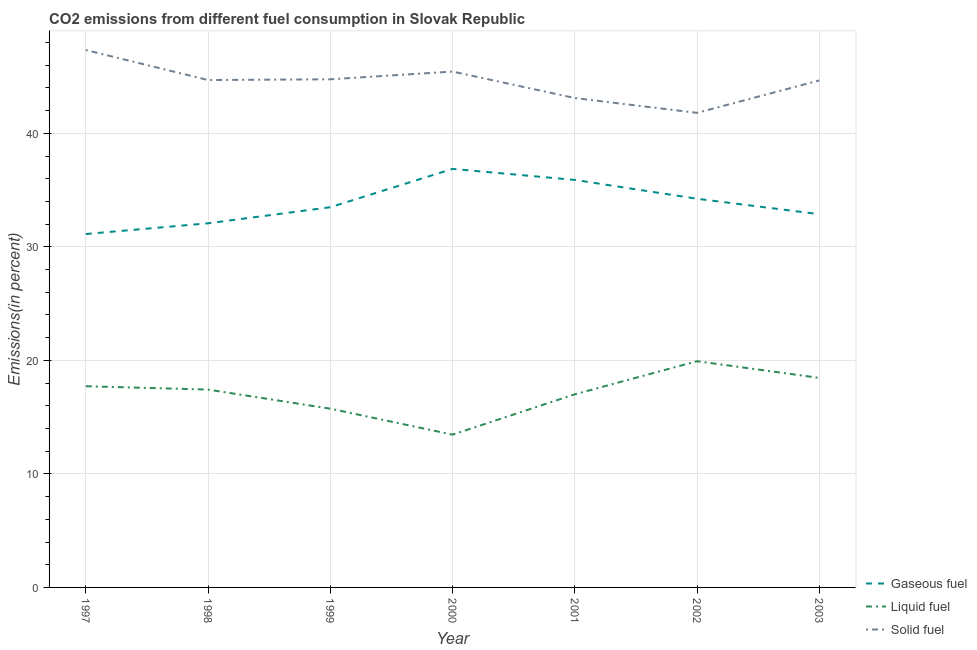How many different coloured lines are there?
Ensure brevity in your answer.  3. Is the number of lines equal to the number of legend labels?
Your response must be concise. Yes. What is the percentage of liquid fuel emission in 1998?
Your answer should be very brief. 17.43. Across all years, what is the maximum percentage of liquid fuel emission?
Offer a terse response. 19.93. Across all years, what is the minimum percentage of solid fuel emission?
Offer a terse response. 41.81. What is the total percentage of solid fuel emission in the graph?
Offer a terse response. 311.82. What is the difference between the percentage of liquid fuel emission in 2001 and that in 2003?
Offer a terse response. -1.45. What is the difference between the percentage of solid fuel emission in 2003 and the percentage of liquid fuel emission in 1998?
Provide a succinct answer. 27.23. What is the average percentage of liquid fuel emission per year?
Provide a succinct answer. 17.11. In the year 2002, what is the difference between the percentage of gaseous fuel emission and percentage of solid fuel emission?
Keep it short and to the point. -7.57. What is the ratio of the percentage of solid fuel emission in 1998 to that in 2001?
Ensure brevity in your answer.  1.04. Is the percentage of liquid fuel emission in 2002 less than that in 2003?
Offer a terse response. No. What is the difference between the highest and the second highest percentage of liquid fuel emission?
Provide a succinct answer. 1.47. What is the difference between the highest and the lowest percentage of solid fuel emission?
Make the answer very short. 5.53. In how many years, is the percentage of gaseous fuel emission greater than the average percentage of gaseous fuel emission taken over all years?
Make the answer very short. 3. Is it the case that in every year, the sum of the percentage of gaseous fuel emission and percentage of liquid fuel emission is greater than the percentage of solid fuel emission?
Provide a succinct answer. Yes. Is the percentage of liquid fuel emission strictly less than the percentage of gaseous fuel emission over the years?
Give a very brief answer. Yes. What is the difference between two consecutive major ticks on the Y-axis?
Your response must be concise. 10. Does the graph contain grids?
Give a very brief answer. Yes. Where does the legend appear in the graph?
Your answer should be very brief. Bottom right. How many legend labels are there?
Your answer should be compact. 3. What is the title of the graph?
Ensure brevity in your answer.  CO2 emissions from different fuel consumption in Slovak Republic. Does "Transport equipments" appear as one of the legend labels in the graph?
Keep it short and to the point. No. What is the label or title of the Y-axis?
Offer a terse response. Emissions(in percent). What is the Emissions(in percent) in Gaseous fuel in 1997?
Provide a succinct answer. 31.13. What is the Emissions(in percent) in Liquid fuel in 1997?
Ensure brevity in your answer.  17.72. What is the Emissions(in percent) in Solid fuel in 1997?
Offer a very short reply. 47.34. What is the Emissions(in percent) in Gaseous fuel in 1998?
Give a very brief answer. 32.08. What is the Emissions(in percent) in Liquid fuel in 1998?
Give a very brief answer. 17.43. What is the Emissions(in percent) in Solid fuel in 1998?
Give a very brief answer. 44.7. What is the Emissions(in percent) of Gaseous fuel in 1999?
Your answer should be compact. 33.49. What is the Emissions(in percent) in Liquid fuel in 1999?
Offer a terse response. 15.75. What is the Emissions(in percent) of Solid fuel in 1999?
Offer a terse response. 44.76. What is the Emissions(in percent) of Gaseous fuel in 2000?
Your response must be concise. 36.87. What is the Emissions(in percent) in Liquid fuel in 2000?
Provide a short and direct response. 13.46. What is the Emissions(in percent) in Solid fuel in 2000?
Ensure brevity in your answer.  45.44. What is the Emissions(in percent) in Gaseous fuel in 2001?
Ensure brevity in your answer.  35.9. What is the Emissions(in percent) of Liquid fuel in 2001?
Keep it short and to the point. 17.01. What is the Emissions(in percent) in Solid fuel in 2001?
Provide a short and direct response. 43.11. What is the Emissions(in percent) in Gaseous fuel in 2002?
Provide a succinct answer. 34.24. What is the Emissions(in percent) in Liquid fuel in 2002?
Your response must be concise. 19.93. What is the Emissions(in percent) of Solid fuel in 2002?
Your answer should be very brief. 41.81. What is the Emissions(in percent) of Gaseous fuel in 2003?
Your response must be concise. 32.88. What is the Emissions(in percent) in Liquid fuel in 2003?
Offer a very short reply. 18.46. What is the Emissions(in percent) of Solid fuel in 2003?
Your answer should be compact. 44.66. Across all years, what is the maximum Emissions(in percent) in Gaseous fuel?
Ensure brevity in your answer.  36.87. Across all years, what is the maximum Emissions(in percent) of Liquid fuel?
Provide a succinct answer. 19.93. Across all years, what is the maximum Emissions(in percent) of Solid fuel?
Your response must be concise. 47.34. Across all years, what is the minimum Emissions(in percent) of Gaseous fuel?
Your response must be concise. 31.13. Across all years, what is the minimum Emissions(in percent) in Liquid fuel?
Offer a very short reply. 13.46. Across all years, what is the minimum Emissions(in percent) of Solid fuel?
Your response must be concise. 41.81. What is the total Emissions(in percent) in Gaseous fuel in the graph?
Make the answer very short. 236.59. What is the total Emissions(in percent) in Liquid fuel in the graph?
Provide a short and direct response. 119.76. What is the total Emissions(in percent) of Solid fuel in the graph?
Your answer should be compact. 311.82. What is the difference between the Emissions(in percent) in Gaseous fuel in 1997 and that in 1998?
Give a very brief answer. -0.94. What is the difference between the Emissions(in percent) of Liquid fuel in 1997 and that in 1998?
Offer a terse response. 0.29. What is the difference between the Emissions(in percent) in Solid fuel in 1997 and that in 1998?
Your answer should be compact. 2.64. What is the difference between the Emissions(in percent) in Gaseous fuel in 1997 and that in 1999?
Provide a short and direct response. -2.36. What is the difference between the Emissions(in percent) of Liquid fuel in 1997 and that in 1999?
Provide a succinct answer. 1.98. What is the difference between the Emissions(in percent) in Solid fuel in 1997 and that in 1999?
Offer a very short reply. 2.58. What is the difference between the Emissions(in percent) of Gaseous fuel in 1997 and that in 2000?
Provide a succinct answer. -5.74. What is the difference between the Emissions(in percent) in Liquid fuel in 1997 and that in 2000?
Your answer should be compact. 4.27. What is the difference between the Emissions(in percent) in Solid fuel in 1997 and that in 2000?
Your answer should be very brief. 1.9. What is the difference between the Emissions(in percent) in Gaseous fuel in 1997 and that in 2001?
Provide a short and direct response. -4.77. What is the difference between the Emissions(in percent) in Liquid fuel in 1997 and that in 2001?
Your answer should be very brief. 0.71. What is the difference between the Emissions(in percent) in Solid fuel in 1997 and that in 2001?
Make the answer very short. 4.23. What is the difference between the Emissions(in percent) of Gaseous fuel in 1997 and that in 2002?
Offer a terse response. -3.11. What is the difference between the Emissions(in percent) of Liquid fuel in 1997 and that in 2002?
Ensure brevity in your answer.  -2.2. What is the difference between the Emissions(in percent) in Solid fuel in 1997 and that in 2002?
Make the answer very short. 5.53. What is the difference between the Emissions(in percent) of Gaseous fuel in 1997 and that in 2003?
Provide a succinct answer. -1.75. What is the difference between the Emissions(in percent) of Liquid fuel in 1997 and that in 2003?
Provide a succinct answer. -0.73. What is the difference between the Emissions(in percent) in Solid fuel in 1997 and that in 2003?
Your response must be concise. 2.68. What is the difference between the Emissions(in percent) of Gaseous fuel in 1998 and that in 1999?
Provide a succinct answer. -1.42. What is the difference between the Emissions(in percent) in Liquid fuel in 1998 and that in 1999?
Your answer should be very brief. 1.68. What is the difference between the Emissions(in percent) in Solid fuel in 1998 and that in 1999?
Offer a terse response. -0.07. What is the difference between the Emissions(in percent) of Gaseous fuel in 1998 and that in 2000?
Provide a succinct answer. -4.79. What is the difference between the Emissions(in percent) of Liquid fuel in 1998 and that in 2000?
Offer a terse response. 3.97. What is the difference between the Emissions(in percent) of Solid fuel in 1998 and that in 2000?
Give a very brief answer. -0.75. What is the difference between the Emissions(in percent) in Gaseous fuel in 1998 and that in 2001?
Your answer should be very brief. -3.82. What is the difference between the Emissions(in percent) of Liquid fuel in 1998 and that in 2001?
Your answer should be very brief. 0.42. What is the difference between the Emissions(in percent) of Solid fuel in 1998 and that in 2001?
Keep it short and to the point. 1.59. What is the difference between the Emissions(in percent) of Gaseous fuel in 1998 and that in 2002?
Make the answer very short. -2.16. What is the difference between the Emissions(in percent) in Liquid fuel in 1998 and that in 2002?
Provide a succinct answer. -2.5. What is the difference between the Emissions(in percent) of Solid fuel in 1998 and that in 2002?
Keep it short and to the point. 2.89. What is the difference between the Emissions(in percent) in Gaseous fuel in 1998 and that in 2003?
Provide a short and direct response. -0.8. What is the difference between the Emissions(in percent) of Liquid fuel in 1998 and that in 2003?
Offer a terse response. -1.03. What is the difference between the Emissions(in percent) in Solid fuel in 1998 and that in 2003?
Offer a very short reply. 0.04. What is the difference between the Emissions(in percent) of Gaseous fuel in 1999 and that in 2000?
Your answer should be very brief. -3.38. What is the difference between the Emissions(in percent) in Liquid fuel in 1999 and that in 2000?
Provide a short and direct response. 2.29. What is the difference between the Emissions(in percent) of Solid fuel in 1999 and that in 2000?
Offer a terse response. -0.68. What is the difference between the Emissions(in percent) of Gaseous fuel in 1999 and that in 2001?
Keep it short and to the point. -2.41. What is the difference between the Emissions(in percent) in Liquid fuel in 1999 and that in 2001?
Make the answer very short. -1.27. What is the difference between the Emissions(in percent) of Solid fuel in 1999 and that in 2001?
Your answer should be compact. 1.65. What is the difference between the Emissions(in percent) in Gaseous fuel in 1999 and that in 2002?
Keep it short and to the point. -0.75. What is the difference between the Emissions(in percent) of Liquid fuel in 1999 and that in 2002?
Offer a terse response. -4.18. What is the difference between the Emissions(in percent) in Solid fuel in 1999 and that in 2002?
Your answer should be compact. 2.96. What is the difference between the Emissions(in percent) in Gaseous fuel in 1999 and that in 2003?
Your response must be concise. 0.61. What is the difference between the Emissions(in percent) of Liquid fuel in 1999 and that in 2003?
Ensure brevity in your answer.  -2.71. What is the difference between the Emissions(in percent) of Solid fuel in 1999 and that in 2003?
Offer a very short reply. 0.1. What is the difference between the Emissions(in percent) of Gaseous fuel in 2000 and that in 2001?
Offer a very short reply. 0.97. What is the difference between the Emissions(in percent) of Liquid fuel in 2000 and that in 2001?
Provide a succinct answer. -3.55. What is the difference between the Emissions(in percent) in Solid fuel in 2000 and that in 2001?
Provide a succinct answer. 2.33. What is the difference between the Emissions(in percent) of Gaseous fuel in 2000 and that in 2002?
Your answer should be compact. 2.63. What is the difference between the Emissions(in percent) of Liquid fuel in 2000 and that in 2002?
Your answer should be very brief. -6.47. What is the difference between the Emissions(in percent) in Solid fuel in 2000 and that in 2002?
Offer a very short reply. 3.64. What is the difference between the Emissions(in percent) of Gaseous fuel in 2000 and that in 2003?
Your response must be concise. 3.99. What is the difference between the Emissions(in percent) of Liquid fuel in 2000 and that in 2003?
Offer a terse response. -5. What is the difference between the Emissions(in percent) of Solid fuel in 2000 and that in 2003?
Ensure brevity in your answer.  0.78. What is the difference between the Emissions(in percent) of Gaseous fuel in 2001 and that in 2002?
Your answer should be very brief. 1.66. What is the difference between the Emissions(in percent) in Liquid fuel in 2001 and that in 2002?
Your response must be concise. -2.91. What is the difference between the Emissions(in percent) of Solid fuel in 2001 and that in 2002?
Make the answer very short. 1.3. What is the difference between the Emissions(in percent) of Gaseous fuel in 2001 and that in 2003?
Your answer should be compact. 3.02. What is the difference between the Emissions(in percent) in Liquid fuel in 2001 and that in 2003?
Ensure brevity in your answer.  -1.45. What is the difference between the Emissions(in percent) in Solid fuel in 2001 and that in 2003?
Make the answer very short. -1.55. What is the difference between the Emissions(in percent) of Gaseous fuel in 2002 and that in 2003?
Provide a succinct answer. 1.36. What is the difference between the Emissions(in percent) of Liquid fuel in 2002 and that in 2003?
Provide a succinct answer. 1.47. What is the difference between the Emissions(in percent) in Solid fuel in 2002 and that in 2003?
Your answer should be compact. -2.85. What is the difference between the Emissions(in percent) of Gaseous fuel in 1997 and the Emissions(in percent) of Liquid fuel in 1998?
Provide a succinct answer. 13.7. What is the difference between the Emissions(in percent) in Gaseous fuel in 1997 and the Emissions(in percent) in Solid fuel in 1998?
Give a very brief answer. -13.56. What is the difference between the Emissions(in percent) of Liquid fuel in 1997 and the Emissions(in percent) of Solid fuel in 1998?
Provide a succinct answer. -26.97. What is the difference between the Emissions(in percent) in Gaseous fuel in 1997 and the Emissions(in percent) in Liquid fuel in 1999?
Your answer should be very brief. 15.39. What is the difference between the Emissions(in percent) in Gaseous fuel in 1997 and the Emissions(in percent) in Solid fuel in 1999?
Your answer should be very brief. -13.63. What is the difference between the Emissions(in percent) in Liquid fuel in 1997 and the Emissions(in percent) in Solid fuel in 1999?
Your answer should be very brief. -27.04. What is the difference between the Emissions(in percent) in Gaseous fuel in 1997 and the Emissions(in percent) in Liquid fuel in 2000?
Your response must be concise. 17.67. What is the difference between the Emissions(in percent) of Gaseous fuel in 1997 and the Emissions(in percent) of Solid fuel in 2000?
Keep it short and to the point. -14.31. What is the difference between the Emissions(in percent) of Liquid fuel in 1997 and the Emissions(in percent) of Solid fuel in 2000?
Make the answer very short. -27.72. What is the difference between the Emissions(in percent) of Gaseous fuel in 1997 and the Emissions(in percent) of Liquid fuel in 2001?
Your response must be concise. 14.12. What is the difference between the Emissions(in percent) of Gaseous fuel in 1997 and the Emissions(in percent) of Solid fuel in 2001?
Ensure brevity in your answer.  -11.98. What is the difference between the Emissions(in percent) in Liquid fuel in 1997 and the Emissions(in percent) in Solid fuel in 2001?
Your answer should be very brief. -25.39. What is the difference between the Emissions(in percent) in Gaseous fuel in 1997 and the Emissions(in percent) in Liquid fuel in 2002?
Your response must be concise. 11.21. What is the difference between the Emissions(in percent) of Gaseous fuel in 1997 and the Emissions(in percent) of Solid fuel in 2002?
Your answer should be very brief. -10.67. What is the difference between the Emissions(in percent) in Liquid fuel in 1997 and the Emissions(in percent) in Solid fuel in 2002?
Make the answer very short. -24.08. What is the difference between the Emissions(in percent) of Gaseous fuel in 1997 and the Emissions(in percent) of Liquid fuel in 2003?
Keep it short and to the point. 12.67. What is the difference between the Emissions(in percent) of Gaseous fuel in 1997 and the Emissions(in percent) of Solid fuel in 2003?
Provide a succinct answer. -13.53. What is the difference between the Emissions(in percent) of Liquid fuel in 1997 and the Emissions(in percent) of Solid fuel in 2003?
Offer a terse response. -26.94. What is the difference between the Emissions(in percent) of Gaseous fuel in 1998 and the Emissions(in percent) of Liquid fuel in 1999?
Your response must be concise. 16.33. What is the difference between the Emissions(in percent) of Gaseous fuel in 1998 and the Emissions(in percent) of Solid fuel in 1999?
Offer a very short reply. -12.69. What is the difference between the Emissions(in percent) in Liquid fuel in 1998 and the Emissions(in percent) in Solid fuel in 1999?
Give a very brief answer. -27.33. What is the difference between the Emissions(in percent) of Gaseous fuel in 1998 and the Emissions(in percent) of Liquid fuel in 2000?
Your answer should be compact. 18.62. What is the difference between the Emissions(in percent) in Gaseous fuel in 1998 and the Emissions(in percent) in Solid fuel in 2000?
Your answer should be compact. -13.37. What is the difference between the Emissions(in percent) of Liquid fuel in 1998 and the Emissions(in percent) of Solid fuel in 2000?
Give a very brief answer. -28.01. What is the difference between the Emissions(in percent) in Gaseous fuel in 1998 and the Emissions(in percent) in Liquid fuel in 2001?
Offer a terse response. 15.06. What is the difference between the Emissions(in percent) in Gaseous fuel in 1998 and the Emissions(in percent) in Solid fuel in 2001?
Provide a short and direct response. -11.03. What is the difference between the Emissions(in percent) in Liquid fuel in 1998 and the Emissions(in percent) in Solid fuel in 2001?
Offer a terse response. -25.68. What is the difference between the Emissions(in percent) of Gaseous fuel in 1998 and the Emissions(in percent) of Liquid fuel in 2002?
Give a very brief answer. 12.15. What is the difference between the Emissions(in percent) in Gaseous fuel in 1998 and the Emissions(in percent) in Solid fuel in 2002?
Keep it short and to the point. -9.73. What is the difference between the Emissions(in percent) of Liquid fuel in 1998 and the Emissions(in percent) of Solid fuel in 2002?
Provide a short and direct response. -24.38. What is the difference between the Emissions(in percent) of Gaseous fuel in 1998 and the Emissions(in percent) of Liquid fuel in 2003?
Make the answer very short. 13.62. What is the difference between the Emissions(in percent) of Gaseous fuel in 1998 and the Emissions(in percent) of Solid fuel in 2003?
Ensure brevity in your answer.  -12.58. What is the difference between the Emissions(in percent) in Liquid fuel in 1998 and the Emissions(in percent) in Solid fuel in 2003?
Provide a succinct answer. -27.23. What is the difference between the Emissions(in percent) of Gaseous fuel in 1999 and the Emissions(in percent) of Liquid fuel in 2000?
Make the answer very short. 20.03. What is the difference between the Emissions(in percent) in Gaseous fuel in 1999 and the Emissions(in percent) in Solid fuel in 2000?
Your answer should be compact. -11.95. What is the difference between the Emissions(in percent) in Liquid fuel in 1999 and the Emissions(in percent) in Solid fuel in 2000?
Provide a short and direct response. -29.7. What is the difference between the Emissions(in percent) in Gaseous fuel in 1999 and the Emissions(in percent) in Liquid fuel in 2001?
Provide a succinct answer. 16.48. What is the difference between the Emissions(in percent) of Gaseous fuel in 1999 and the Emissions(in percent) of Solid fuel in 2001?
Provide a succinct answer. -9.62. What is the difference between the Emissions(in percent) of Liquid fuel in 1999 and the Emissions(in percent) of Solid fuel in 2001?
Make the answer very short. -27.36. What is the difference between the Emissions(in percent) in Gaseous fuel in 1999 and the Emissions(in percent) in Liquid fuel in 2002?
Your answer should be compact. 13.57. What is the difference between the Emissions(in percent) in Gaseous fuel in 1999 and the Emissions(in percent) in Solid fuel in 2002?
Make the answer very short. -8.31. What is the difference between the Emissions(in percent) in Liquid fuel in 1999 and the Emissions(in percent) in Solid fuel in 2002?
Provide a succinct answer. -26.06. What is the difference between the Emissions(in percent) in Gaseous fuel in 1999 and the Emissions(in percent) in Liquid fuel in 2003?
Ensure brevity in your answer.  15.03. What is the difference between the Emissions(in percent) in Gaseous fuel in 1999 and the Emissions(in percent) in Solid fuel in 2003?
Your response must be concise. -11.17. What is the difference between the Emissions(in percent) of Liquid fuel in 1999 and the Emissions(in percent) of Solid fuel in 2003?
Your answer should be very brief. -28.91. What is the difference between the Emissions(in percent) of Gaseous fuel in 2000 and the Emissions(in percent) of Liquid fuel in 2001?
Give a very brief answer. 19.86. What is the difference between the Emissions(in percent) in Gaseous fuel in 2000 and the Emissions(in percent) in Solid fuel in 2001?
Keep it short and to the point. -6.24. What is the difference between the Emissions(in percent) of Liquid fuel in 2000 and the Emissions(in percent) of Solid fuel in 2001?
Ensure brevity in your answer.  -29.65. What is the difference between the Emissions(in percent) in Gaseous fuel in 2000 and the Emissions(in percent) in Liquid fuel in 2002?
Provide a short and direct response. 16.94. What is the difference between the Emissions(in percent) of Gaseous fuel in 2000 and the Emissions(in percent) of Solid fuel in 2002?
Offer a very short reply. -4.94. What is the difference between the Emissions(in percent) of Liquid fuel in 2000 and the Emissions(in percent) of Solid fuel in 2002?
Offer a terse response. -28.35. What is the difference between the Emissions(in percent) in Gaseous fuel in 2000 and the Emissions(in percent) in Liquid fuel in 2003?
Provide a succinct answer. 18.41. What is the difference between the Emissions(in percent) in Gaseous fuel in 2000 and the Emissions(in percent) in Solid fuel in 2003?
Give a very brief answer. -7.79. What is the difference between the Emissions(in percent) of Liquid fuel in 2000 and the Emissions(in percent) of Solid fuel in 2003?
Offer a terse response. -31.2. What is the difference between the Emissions(in percent) of Gaseous fuel in 2001 and the Emissions(in percent) of Liquid fuel in 2002?
Your answer should be very brief. 15.97. What is the difference between the Emissions(in percent) of Gaseous fuel in 2001 and the Emissions(in percent) of Solid fuel in 2002?
Ensure brevity in your answer.  -5.91. What is the difference between the Emissions(in percent) of Liquid fuel in 2001 and the Emissions(in percent) of Solid fuel in 2002?
Your answer should be very brief. -24.79. What is the difference between the Emissions(in percent) in Gaseous fuel in 2001 and the Emissions(in percent) in Liquid fuel in 2003?
Your response must be concise. 17.44. What is the difference between the Emissions(in percent) in Gaseous fuel in 2001 and the Emissions(in percent) in Solid fuel in 2003?
Ensure brevity in your answer.  -8.76. What is the difference between the Emissions(in percent) of Liquid fuel in 2001 and the Emissions(in percent) of Solid fuel in 2003?
Ensure brevity in your answer.  -27.65. What is the difference between the Emissions(in percent) of Gaseous fuel in 2002 and the Emissions(in percent) of Liquid fuel in 2003?
Your answer should be very brief. 15.78. What is the difference between the Emissions(in percent) in Gaseous fuel in 2002 and the Emissions(in percent) in Solid fuel in 2003?
Ensure brevity in your answer.  -10.42. What is the difference between the Emissions(in percent) of Liquid fuel in 2002 and the Emissions(in percent) of Solid fuel in 2003?
Give a very brief answer. -24.73. What is the average Emissions(in percent) of Gaseous fuel per year?
Your response must be concise. 33.8. What is the average Emissions(in percent) in Liquid fuel per year?
Give a very brief answer. 17.11. What is the average Emissions(in percent) in Solid fuel per year?
Keep it short and to the point. 44.55. In the year 1997, what is the difference between the Emissions(in percent) in Gaseous fuel and Emissions(in percent) in Liquid fuel?
Provide a succinct answer. 13.41. In the year 1997, what is the difference between the Emissions(in percent) of Gaseous fuel and Emissions(in percent) of Solid fuel?
Provide a succinct answer. -16.21. In the year 1997, what is the difference between the Emissions(in percent) of Liquid fuel and Emissions(in percent) of Solid fuel?
Provide a succinct answer. -29.61. In the year 1998, what is the difference between the Emissions(in percent) in Gaseous fuel and Emissions(in percent) in Liquid fuel?
Offer a very short reply. 14.65. In the year 1998, what is the difference between the Emissions(in percent) of Gaseous fuel and Emissions(in percent) of Solid fuel?
Ensure brevity in your answer.  -12.62. In the year 1998, what is the difference between the Emissions(in percent) in Liquid fuel and Emissions(in percent) in Solid fuel?
Provide a short and direct response. -27.27. In the year 1999, what is the difference between the Emissions(in percent) in Gaseous fuel and Emissions(in percent) in Liquid fuel?
Ensure brevity in your answer.  17.75. In the year 1999, what is the difference between the Emissions(in percent) in Gaseous fuel and Emissions(in percent) in Solid fuel?
Offer a very short reply. -11.27. In the year 1999, what is the difference between the Emissions(in percent) of Liquid fuel and Emissions(in percent) of Solid fuel?
Offer a very short reply. -29.02. In the year 2000, what is the difference between the Emissions(in percent) of Gaseous fuel and Emissions(in percent) of Liquid fuel?
Your response must be concise. 23.41. In the year 2000, what is the difference between the Emissions(in percent) of Gaseous fuel and Emissions(in percent) of Solid fuel?
Your response must be concise. -8.57. In the year 2000, what is the difference between the Emissions(in percent) in Liquid fuel and Emissions(in percent) in Solid fuel?
Offer a terse response. -31.98. In the year 2001, what is the difference between the Emissions(in percent) of Gaseous fuel and Emissions(in percent) of Liquid fuel?
Give a very brief answer. 18.89. In the year 2001, what is the difference between the Emissions(in percent) of Gaseous fuel and Emissions(in percent) of Solid fuel?
Your answer should be compact. -7.21. In the year 2001, what is the difference between the Emissions(in percent) of Liquid fuel and Emissions(in percent) of Solid fuel?
Provide a short and direct response. -26.1. In the year 2002, what is the difference between the Emissions(in percent) of Gaseous fuel and Emissions(in percent) of Liquid fuel?
Give a very brief answer. 14.31. In the year 2002, what is the difference between the Emissions(in percent) in Gaseous fuel and Emissions(in percent) in Solid fuel?
Keep it short and to the point. -7.57. In the year 2002, what is the difference between the Emissions(in percent) of Liquid fuel and Emissions(in percent) of Solid fuel?
Offer a terse response. -21.88. In the year 2003, what is the difference between the Emissions(in percent) in Gaseous fuel and Emissions(in percent) in Liquid fuel?
Offer a terse response. 14.42. In the year 2003, what is the difference between the Emissions(in percent) in Gaseous fuel and Emissions(in percent) in Solid fuel?
Provide a succinct answer. -11.78. In the year 2003, what is the difference between the Emissions(in percent) in Liquid fuel and Emissions(in percent) in Solid fuel?
Make the answer very short. -26.2. What is the ratio of the Emissions(in percent) of Gaseous fuel in 1997 to that in 1998?
Provide a succinct answer. 0.97. What is the ratio of the Emissions(in percent) in Liquid fuel in 1997 to that in 1998?
Your response must be concise. 1.02. What is the ratio of the Emissions(in percent) of Solid fuel in 1997 to that in 1998?
Offer a terse response. 1.06. What is the ratio of the Emissions(in percent) of Gaseous fuel in 1997 to that in 1999?
Keep it short and to the point. 0.93. What is the ratio of the Emissions(in percent) of Liquid fuel in 1997 to that in 1999?
Offer a terse response. 1.13. What is the ratio of the Emissions(in percent) of Solid fuel in 1997 to that in 1999?
Keep it short and to the point. 1.06. What is the ratio of the Emissions(in percent) of Gaseous fuel in 1997 to that in 2000?
Your answer should be compact. 0.84. What is the ratio of the Emissions(in percent) in Liquid fuel in 1997 to that in 2000?
Make the answer very short. 1.32. What is the ratio of the Emissions(in percent) of Solid fuel in 1997 to that in 2000?
Provide a short and direct response. 1.04. What is the ratio of the Emissions(in percent) in Gaseous fuel in 1997 to that in 2001?
Keep it short and to the point. 0.87. What is the ratio of the Emissions(in percent) in Liquid fuel in 1997 to that in 2001?
Your answer should be compact. 1.04. What is the ratio of the Emissions(in percent) in Solid fuel in 1997 to that in 2001?
Provide a short and direct response. 1.1. What is the ratio of the Emissions(in percent) of Gaseous fuel in 1997 to that in 2002?
Give a very brief answer. 0.91. What is the ratio of the Emissions(in percent) of Liquid fuel in 1997 to that in 2002?
Make the answer very short. 0.89. What is the ratio of the Emissions(in percent) of Solid fuel in 1997 to that in 2002?
Make the answer very short. 1.13. What is the ratio of the Emissions(in percent) of Gaseous fuel in 1997 to that in 2003?
Give a very brief answer. 0.95. What is the ratio of the Emissions(in percent) of Liquid fuel in 1997 to that in 2003?
Ensure brevity in your answer.  0.96. What is the ratio of the Emissions(in percent) of Solid fuel in 1997 to that in 2003?
Offer a very short reply. 1.06. What is the ratio of the Emissions(in percent) in Gaseous fuel in 1998 to that in 1999?
Your answer should be compact. 0.96. What is the ratio of the Emissions(in percent) in Liquid fuel in 1998 to that in 1999?
Make the answer very short. 1.11. What is the ratio of the Emissions(in percent) of Solid fuel in 1998 to that in 1999?
Offer a terse response. 1. What is the ratio of the Emissions(in percent) of Gaseous fuel in 1998 to that in 2000?
Your answer should be very brief. 0.87. What is the ratio of the Emissions(in percent) of Liquid fuel in 1998 to that in 2000?
Offer a terse response. 1.3. What is the ratio of the Emissions(in percent) of Solid fuel in 1998 to that in 2000?
Your answer should be compact. 0.98. What is the ratio of the Emissions(in percent) of Gaseous fuel in 1998 to that in 2001?
Offer a very short reply. 0.89. What is the ratio of the Emissions(in percent) in Liquid fuel in 1998 to that in 2001?
Give a very brief answer. 1.02. What is the ratio of the Emissions(in percent) in Solid fuel in 1998 to that in 2001?
Provide a short and direct response. 1.04. What is the ratio of the Emissions(in percent) of Gaseous fuel in 1998 to that in 2002?
Provide a short and direct response. 0.94. What is the ratio of the Emissions(in percent) in Liquid fuel in 1998 to that in 2002?
Provide a succinct answer. 0.87. What is the ratio of the Emissions(in percent) in Solid fuel in 1998 to that in 2002?
Ensure brevity in your answer.  1.07. What is the ratio of the Emissions(in percent) of Gaseous fuel in 1998 to that in 2003?
Offer a very short reply. 0.98. What is the ratio of the Emissions(in percent) in Liquid fuel in 1998 to that in 2003?
Provide a short and direct response. 0.94. What is the ratio of the Emissions(in percent) of Gaseous fuel in 1999 to that in 2000?
Keep it short and to the point. 0.91. What is the ratio of the Emissions(in percent) in Liquid fuel in 1999 to that in 2000?
Your response must be concise. 1.17. What is the ratio of the Emissions(in percent) of Gaseous fuel in 1999 to that in 2001?
Provide a short and direct response. 0.93. What is the ratio of the Emissions(in percent) of Liquid fuel in 1999 to that in 2001?
Give a very brief answer. 0.93. What is the ratio of the Emissions(in percent) in Solid fuel in 1999 to that in 2001?
Keep it short and to the point. 1.04. What is the ratio of the Emissions(in percent) of Gaseous fuel in 1999 to that in 2002?
Keep it short and to the point. 0.98. What is the ratio of the Emissions(in percent) in Liquid fuel in 1999 to that in 2002?
Your answer should be compact. 0.79. What is the ratio of the Emissions(in percent) of Solid fuel in 1999 to that in 2002?
Your answer should be very brief. 1.07. What is the ratio of the Emissions(in percent) of Gaseous fuel in 1999 to that in 2003?
Ensure brevity in your answer.  1.02. What is the ratio of the Emissions(in percent) of Liquid fuel in 1999 to that in 2003?
Offer a terse response. 0.85. What is the ratio of the Emissions(in percent) in Solid fuel in 1999 to that in 2003?
Your answer should be compact. 1. What is the ratio of the Emissions(in percent) of Liquid fuel in 2000 to that in 2001?
Your answer should be very brief. 0.79. What is the ratio of the Emissions(in percent) in Solid fuel in 2000 to that in 2001?
Ensure brevity in your answer.  1.05. What is the ratio of the Emissions(in percent) in Gaseous fuel in 2000 to that in 2002?
Offer a terse response. 1.08. What is the ratio of the Emissions(in percent) of Liquid fuel in 2000 to that in 2002?
Provide a succinct answer. 0.68. What is the ratio of the Emissions(in percent) of Solid fuel in 2000 to that in 2002?
Provide a short and direct response. 1.09. What is the ratio of the Emissions(in percent) of Gaseous fuel in 2000 to that in 2003?
Offer a terse response. 1.12. What is the ratio of the Emissions(in percent) in Liquid fuel in 2000 to that in 2003?
Give a very brief answer. 0.73. What is the ratio of the Emissions(in percent) in Solid fuel in 2000 to that in 2003?
Offer a very short reply. 1.02. What is the ratio of the Emissions(in percent) in Gaseous fuel in 2001 to that in 2002?
Offer a very short reply. 1.05. What is the ratio of the Emissions(in percent) in Liquid fuel in 2001 to that in 2002?
Give a very brief answer. 0.85. What is the ratio of the Emissions(in percent) in Solid fuel in 2001 to that in 2002?
Give a very brief answer. 1.03. What is the ratio of the Emissions(in percent) of Gaseous fuel in 2001 to that in 2003?
Offer a terse response. 1.09. What is the ratio of the Emissions(in percent) of Liquid fuel in 2001 to that in 2003?
Offer a terse response. 0.92. What is the ratio of the Emissions(in percent) in Solid fuel in 2001 to that in 2003?
Provide a short and direct response. 0.97. What is the ratio of the Emissions(in percent) of Gaseous fuel in 2002 to that in 2003?
Ensure brevity in your answer.  1.04. What is the ratio of the Emissions(in percent) in Liquid fuel in 2002 to that in 2003?
Offer a terse response. 1.08. What is the ratio of the Emissions(in percent) of Solid fuel in 2002 to that in 2003?
Keep it short and to the point. 0.94. What is the difference between the highest and the second highest Emissions(in percent) in Gaseous fuel?
Make the answer very short. 0.97. What is the difference between the highest and the second highest Emissions(in percent) in Liquid fuel?
Ensure brevity in your answer.  1.47. What is the difference between the highest and the second highest Emissions(in percent) of Solid fuel?
Your answer should be compact. 1.9. What is the difference between the highest and the lowest Emissions(in percent) of Gaseous fuel?
Give a very brief answer. 5.74. What is the difference between the highest and the lowest Emissions(in percent) in Liquid fuel?
Ensure brevity in your answer.  6.47. What is the difference between the highest and the lowest Emissions(in percent) of Solid fuel?
Offer a very short reply. 5.53. 